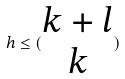<formula> <loc_0><loc_0><loc_500><loc_500>h \leq ( \begin{matrix} k + l \\ k \end{matrix} )</formula> 